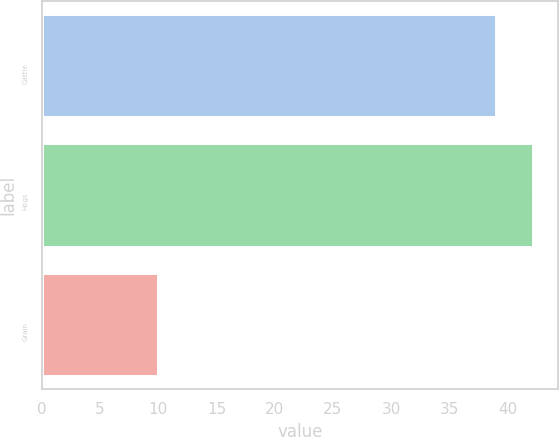<chart> <loc_0><loc_0><loc_500><loc_500><bar_chart><fcel>Cattle<fcel>Hogs<fcel>Grain<nl><fcel>39<fcel>42.2<fcel>10<nl></chart> 